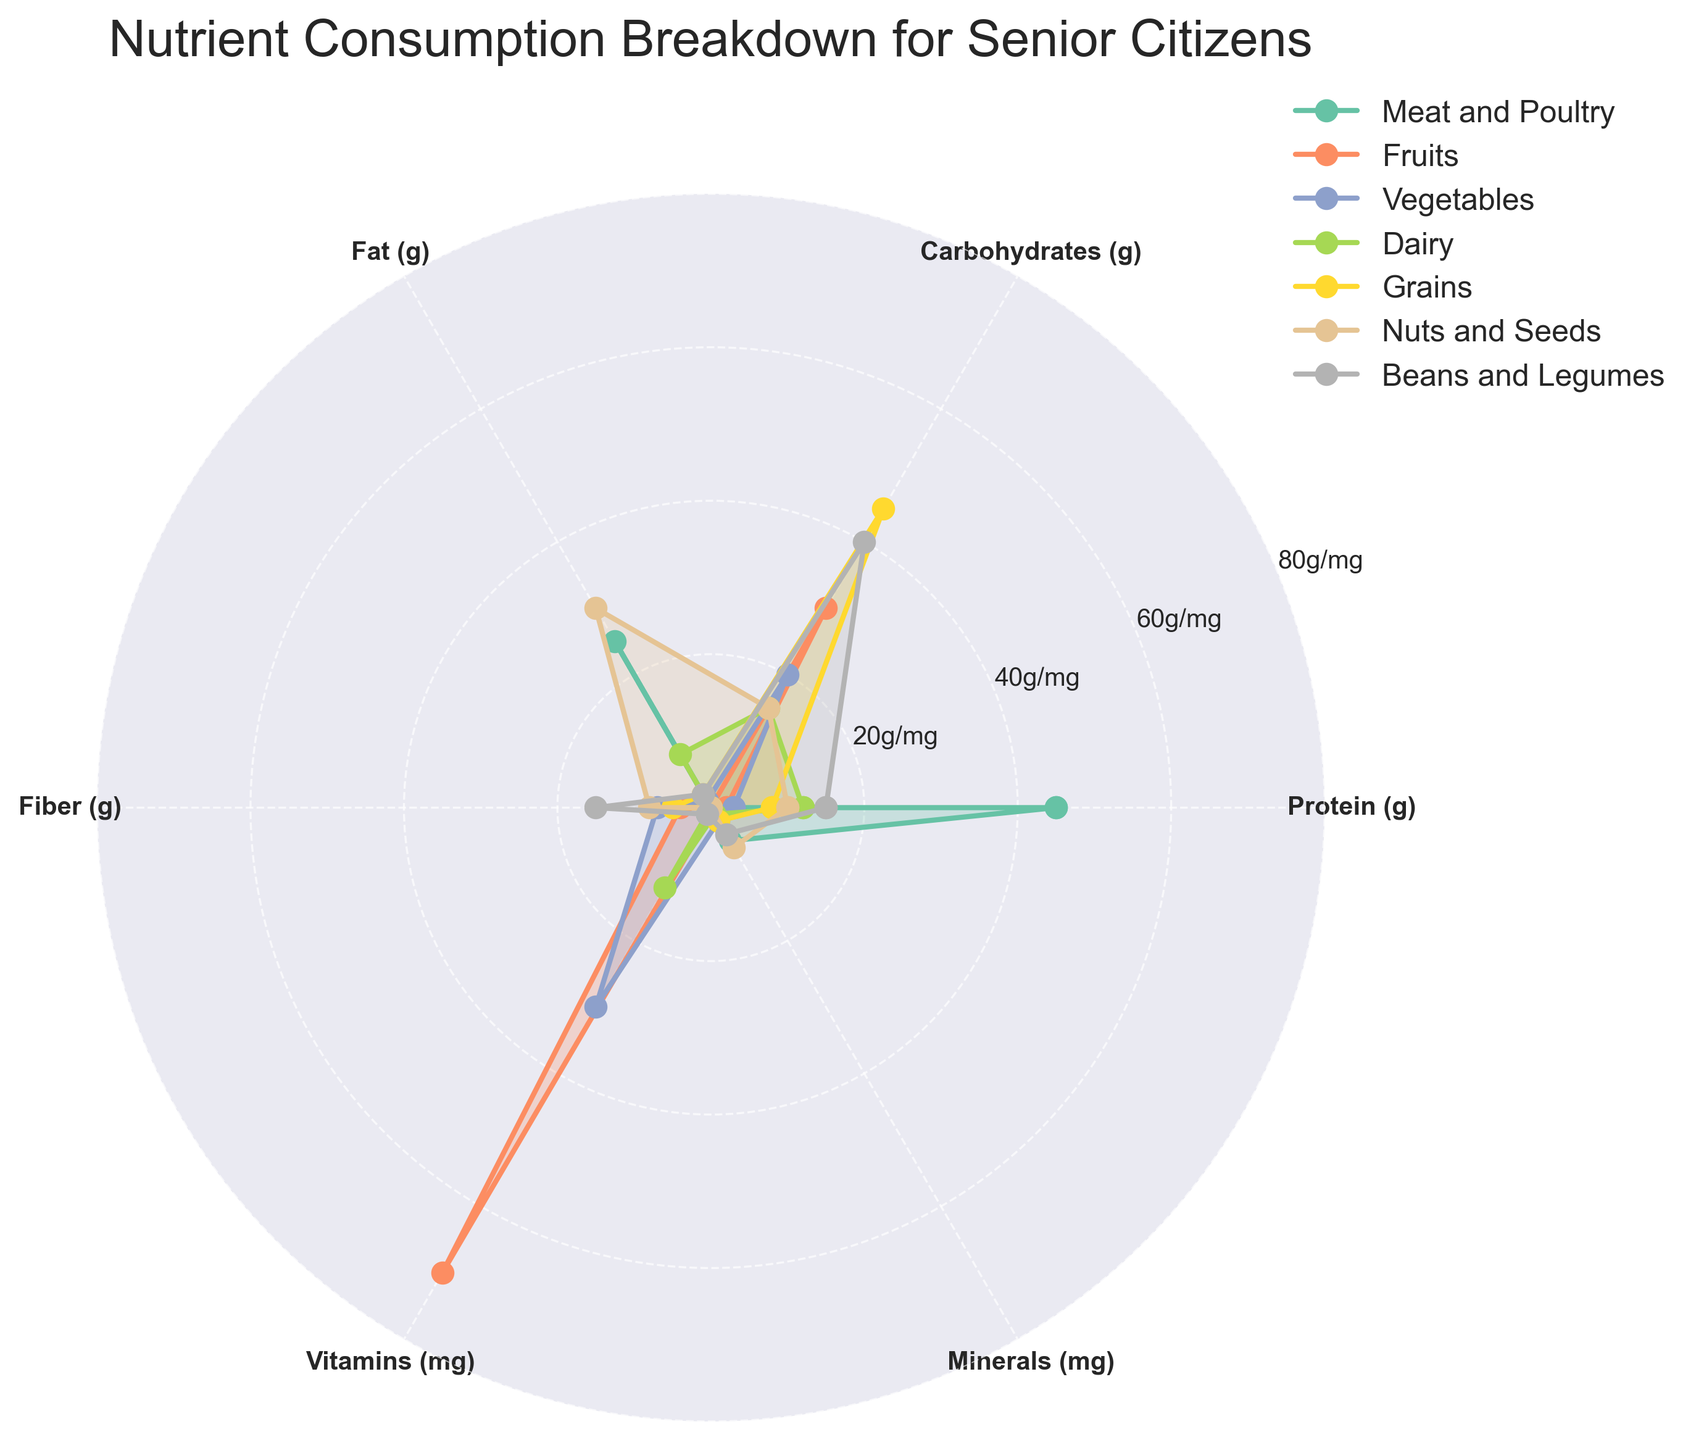What is the title of the chart? The title is displayed at the top center of the chart. It is written in a larger font size for better visibility.
Answer: Nutrient Consumption Breakdown for Senior Citizens Which category has the highest protein content? To determine this, look at all the plot lines for the protein (g) axis and find which category extends the furthest.
Answer: Meat and Poultry How many categories are compared in the chart? Count the number of differently colored plot lines or entries in the legend box on the right side of the chart.
Answer: Seven Which two categories have zero fat content? Observe the values for the Fat (g) axis and identify which plot lines do not extend from the center for this nutrient.
Answer: Fruits and Meat and Poultry What is the average fiber content for Fruits, Vegetables, and Grains combined? Look at the fiber (g) values for Fruits, Vegetables, and Grains. Add these values together and then divide by 3 to find the average. The values are: Fruits (4g), Vegetables (7g), Grains (5g). (4 + 7 + 5) / 3 = 16 / 3 = 5.33
Answer: 5.33g Which category contains the highest value for fiber content, and what is the value? Examine the plot lines around the fiber (g) axis and identify which category reaches out the furthest.
Answer: Beans and Legumes, 15g Are the vitamin contents in Meat and Poultry and Beans and Legumes equal? Compare the length of the plot lines for Vitamins (mg) from the origin for these two categories.
Answer: Yes Which category has the smallest mineral content and what is the value? Look at the Minerals (mg) axis and find which plot line is closest to the center.
Answer: Fruits, 0.5mg Which category has more carbohydrate content: Grains or Beans and Legumes? Compare the extent of the plot lines for Carbohydrates (g) between these two categories. Grains extends to 45g while Beans and Legumes reaches 40g.
Answer: Grains What is the difference in fat content between Dairy and Nuts and Seeds? Look at the Fat (g) axis to find the values for Dairy (8g) and Nuts and Seeds (30g). Subtract these values to find the difference (30g - 8g).
Answer: 22g 